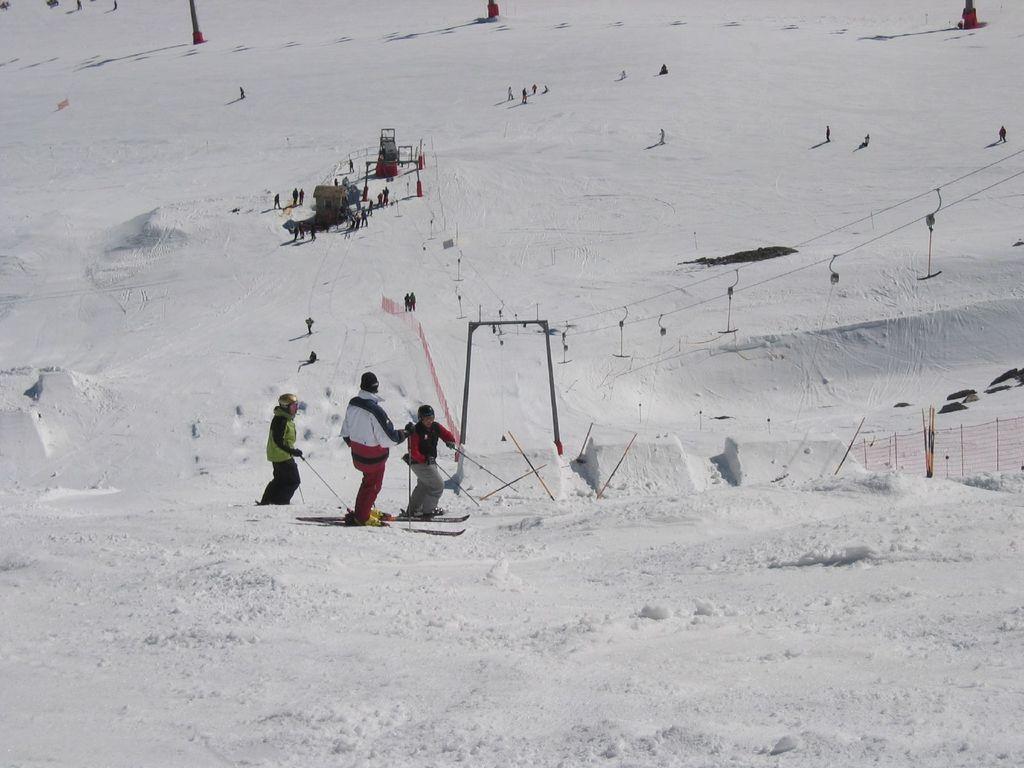In one or two sentences, can you explain what this image depicts? In this image I can see some snow, few persons standing on the ski boards and skiing on the snow and I can see they are holding sticks in their hands. I can see the fencing, few wires, few poles and number of persons standing on the snow in the background. 